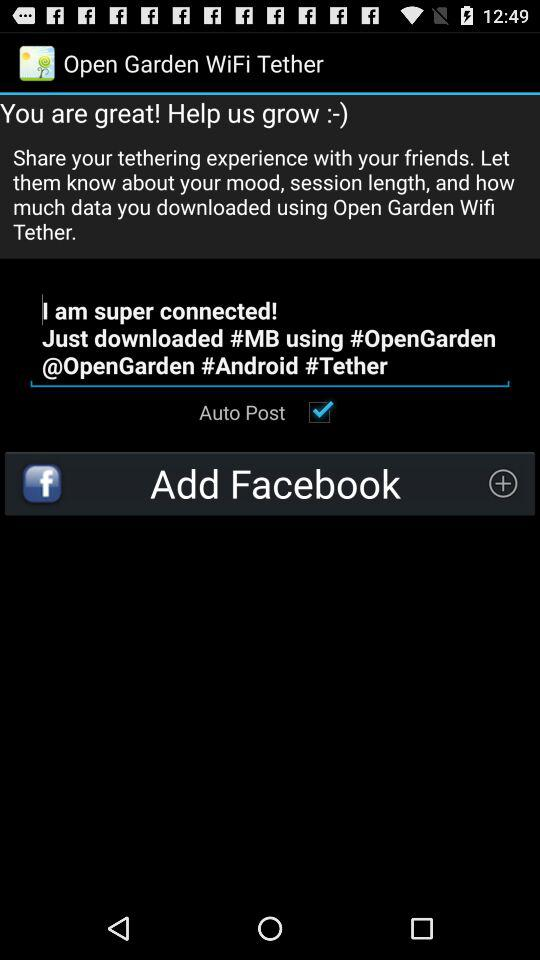How to download #MB?
When the provided information is insufficient, respond with <no answer>. <no answer> 